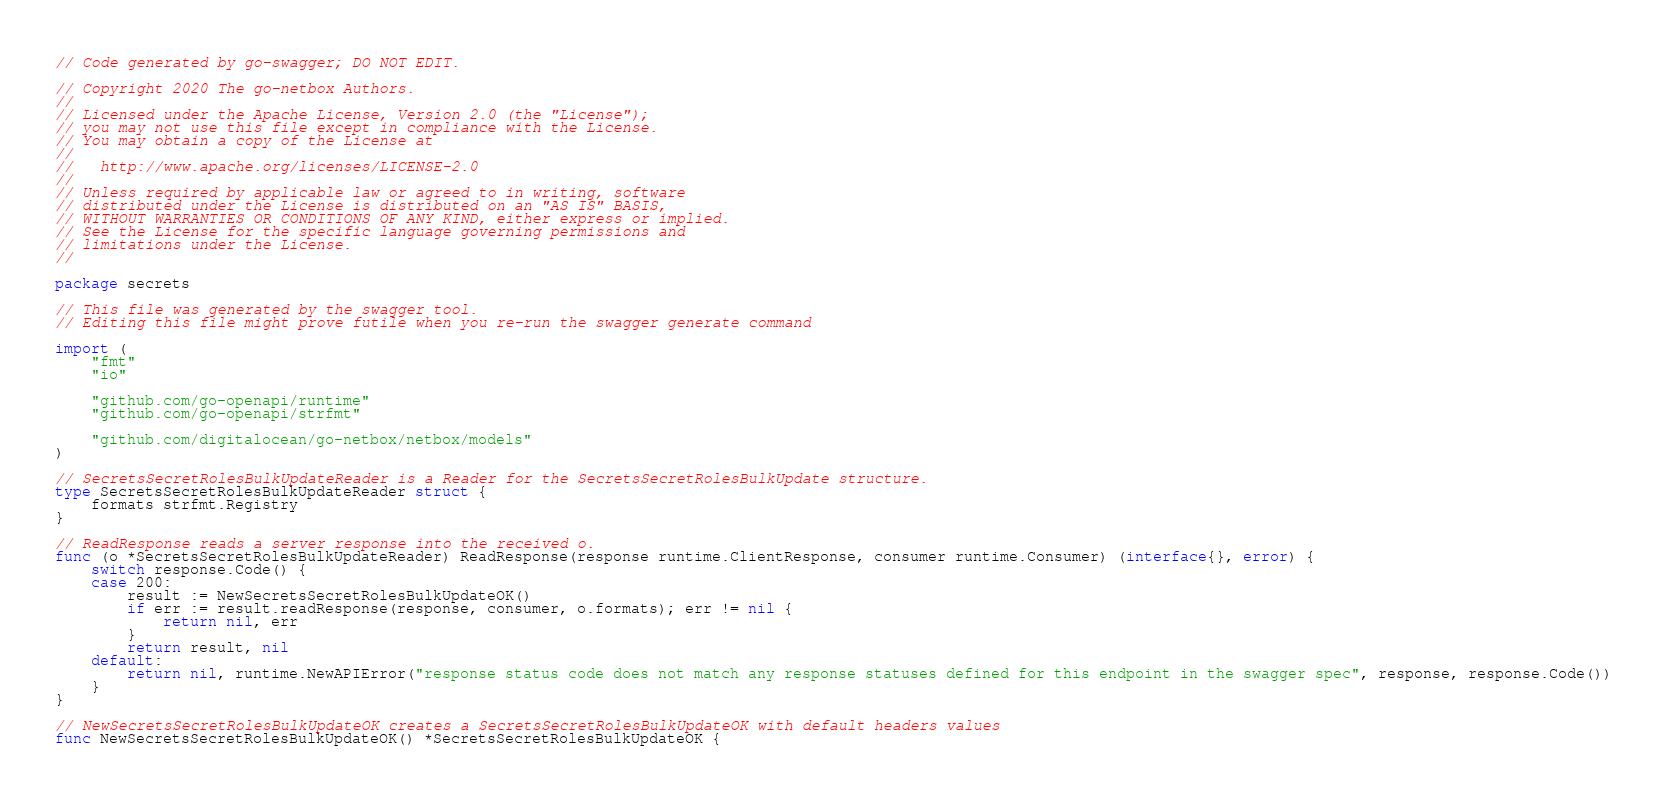<code> <loc_0><loc_0><loc_500><loc_500><_Go_>// Code generated by go-swagger; DO NOT EDIT.

// Copyright 2020 The go-netbox Authors.
//
// Licensed under the Apache License, Version 2.0 (the "License");
// you may not use this file except in compliance with the License.
// You may obtain a copy of the License at
//
//   http://www.apache.org/licenses/LICENSE-2.0
//
// Unless required by applicable law or agreed to in writing, software
// distributed under the License is distributed on an "AS IS" BASIS,
// WITHOUT WARRANTIES OR CONDITIONS OF ANY KIND, either express or implied.
// See the License for the specific language governing permissions and
// limitations under the License.
//

package secrets

// This file was generated by the swagger tool.
// Editing this file might prove futile when you re-run the swagger generate command

import (
	"fmt"
	"io"

	"github.com/go-openapi/runtime"
	"github.com/go-openapi/strfmt"

	"github.com/digitalocean/go-netbox/netbox/models"
)

// SecretsSecretRolesBulkUpdateReader is a Reader for the SecretsSecretRolesBulkUpdate structure.
type SecretsSecretRolesBulkUpdateReader struct {
	formats strfmt.Registry
}

// ReadResponse reads a server response into the received o.
func (o *SecretsSecretRolesBulkUpdateReader) ReadResponse(response runtime.ClientResponse, consumer runtime.Consumer) (interface{}, error) {
	switch response.Code() {
	case 200:
		result := NewSecretsSecretRolesBulkUpdateOK()
		if err := result.readResponse(response, consumer, o.formats); err != nil {
			return nil, err
		}
		return result, nil
	default:
		return nil, runtime.NewAPIError("response status code does not match any response statuses defined for this endpoint in the swagger spec", response, response.Code())
	}
}

// NewSecretsSecretRolesBulkUpdateOK creates a SecretsSecretRolesBulkUpdateOK with default headers values
func NewSecretsSecretRolesBulkUpdateOK() *SecretsSecretRolesBulkUpdateOK {</code> 